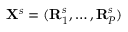Convert formula to latex. <formula><loc_0><loc_0><loc_500><loc_500>\mathbf X ^ { s } = ( \mathbf R _ { 1 } ^ { s } , \dots , \mathbf R _ { P } ^ { s } )</formula> 